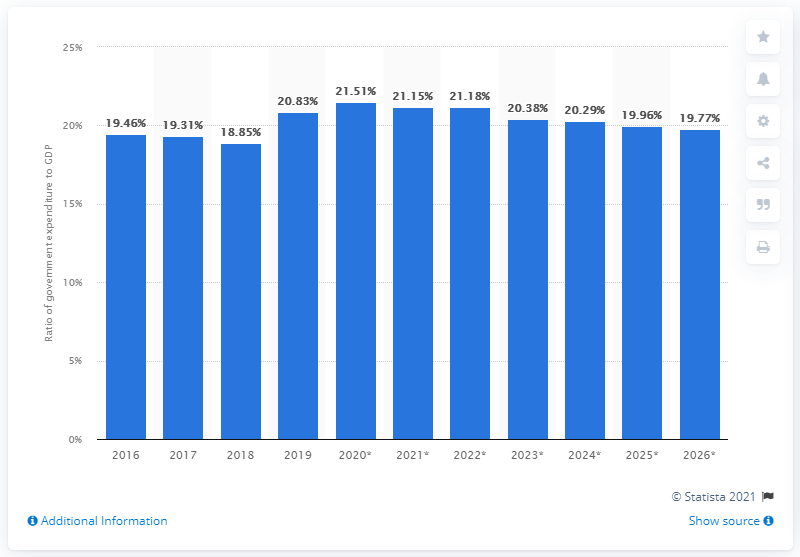Mention a couple of crucial points in this snapshot. In 2019, government expenditure in Sri Lanka accounted for 20.83% of the country's Gross Domestic Product (GDP). 